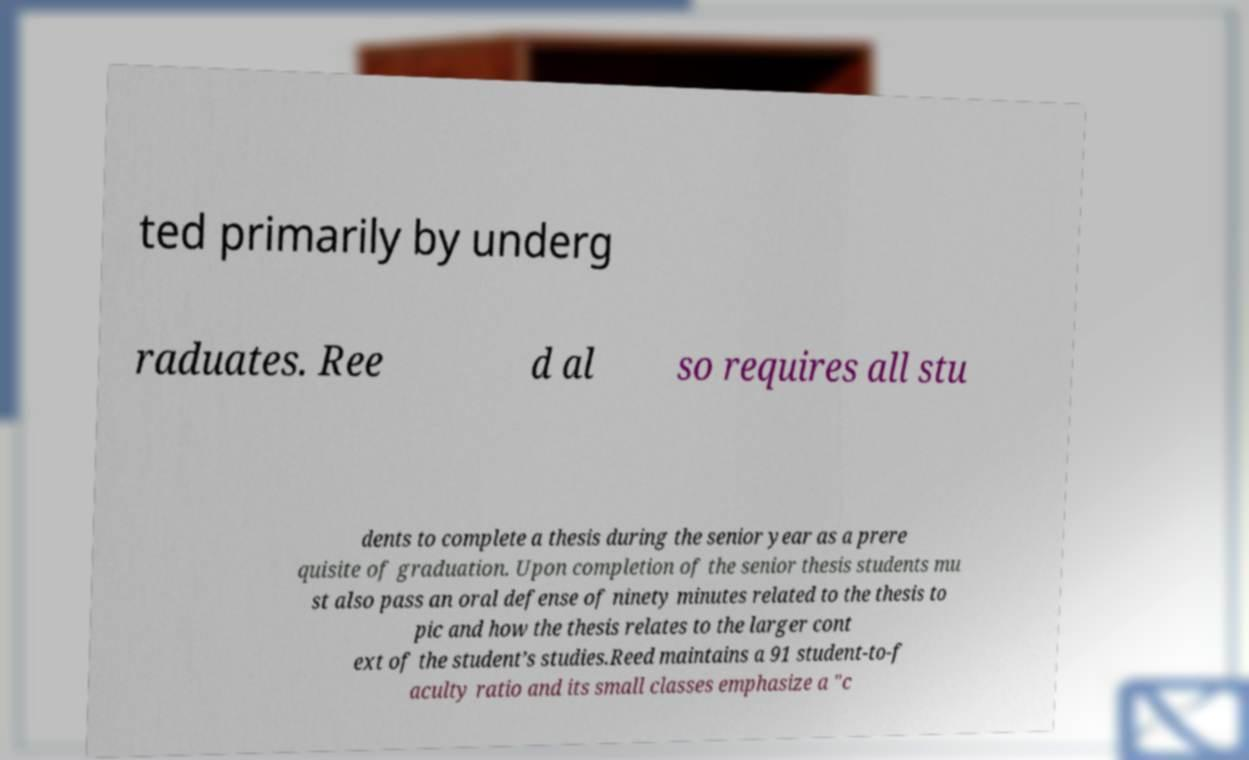Please read and relay the text visible in this image. What does it say? ted primarily by underg raduates. Ree d al so requires all stu dents to complete a thesis during the senior year as a prere quisite of graduation. Upon completion of the senior thesis students mu st also pass an oral defense of ninety minutes related to the thesis to pic and how the thesis relates to the larger cont ext of the student’s studies.Reed maintains a 91 student-to-f aculty ratio and its small classes emphasize a "c 